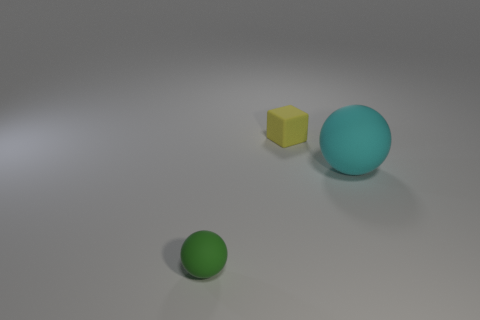What is the possible material of the objects shown in the image? The objects in the image seem to have a matte finish. The cube and larger sphere might be made of a plastic or resin material, while the tiny sphere has a diffuse surface that could suggest a similar composition. 